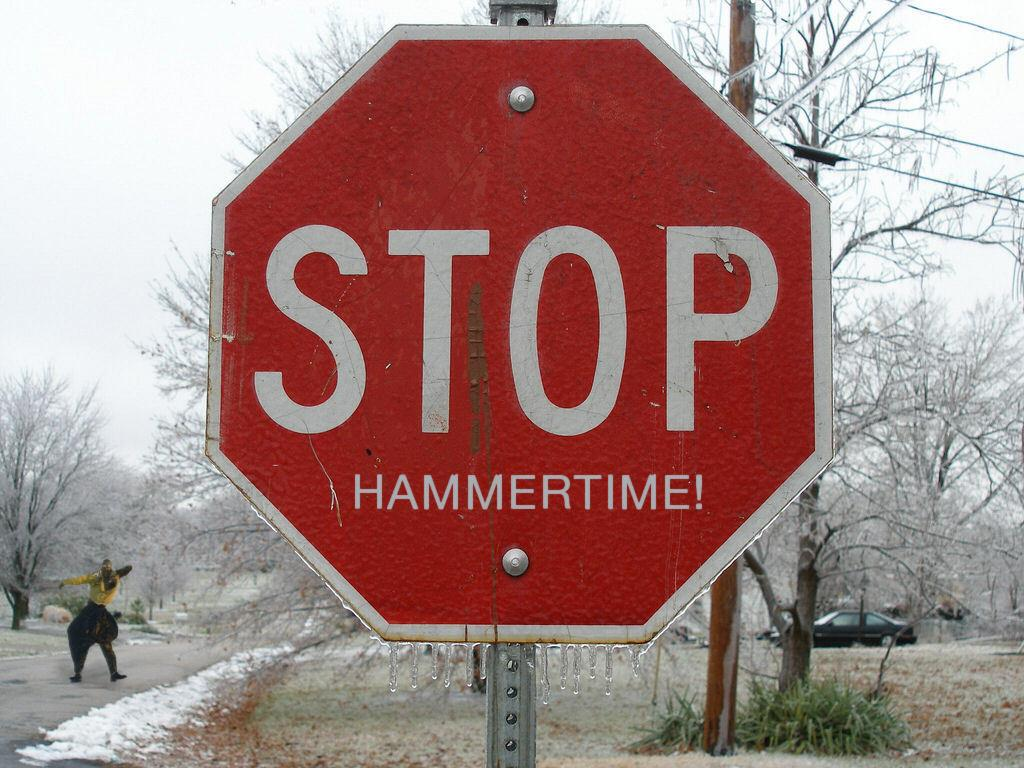<image>
Offer a succinct explanation of the picture presented. A red stop sign with the words "Hammertime!" below it. 